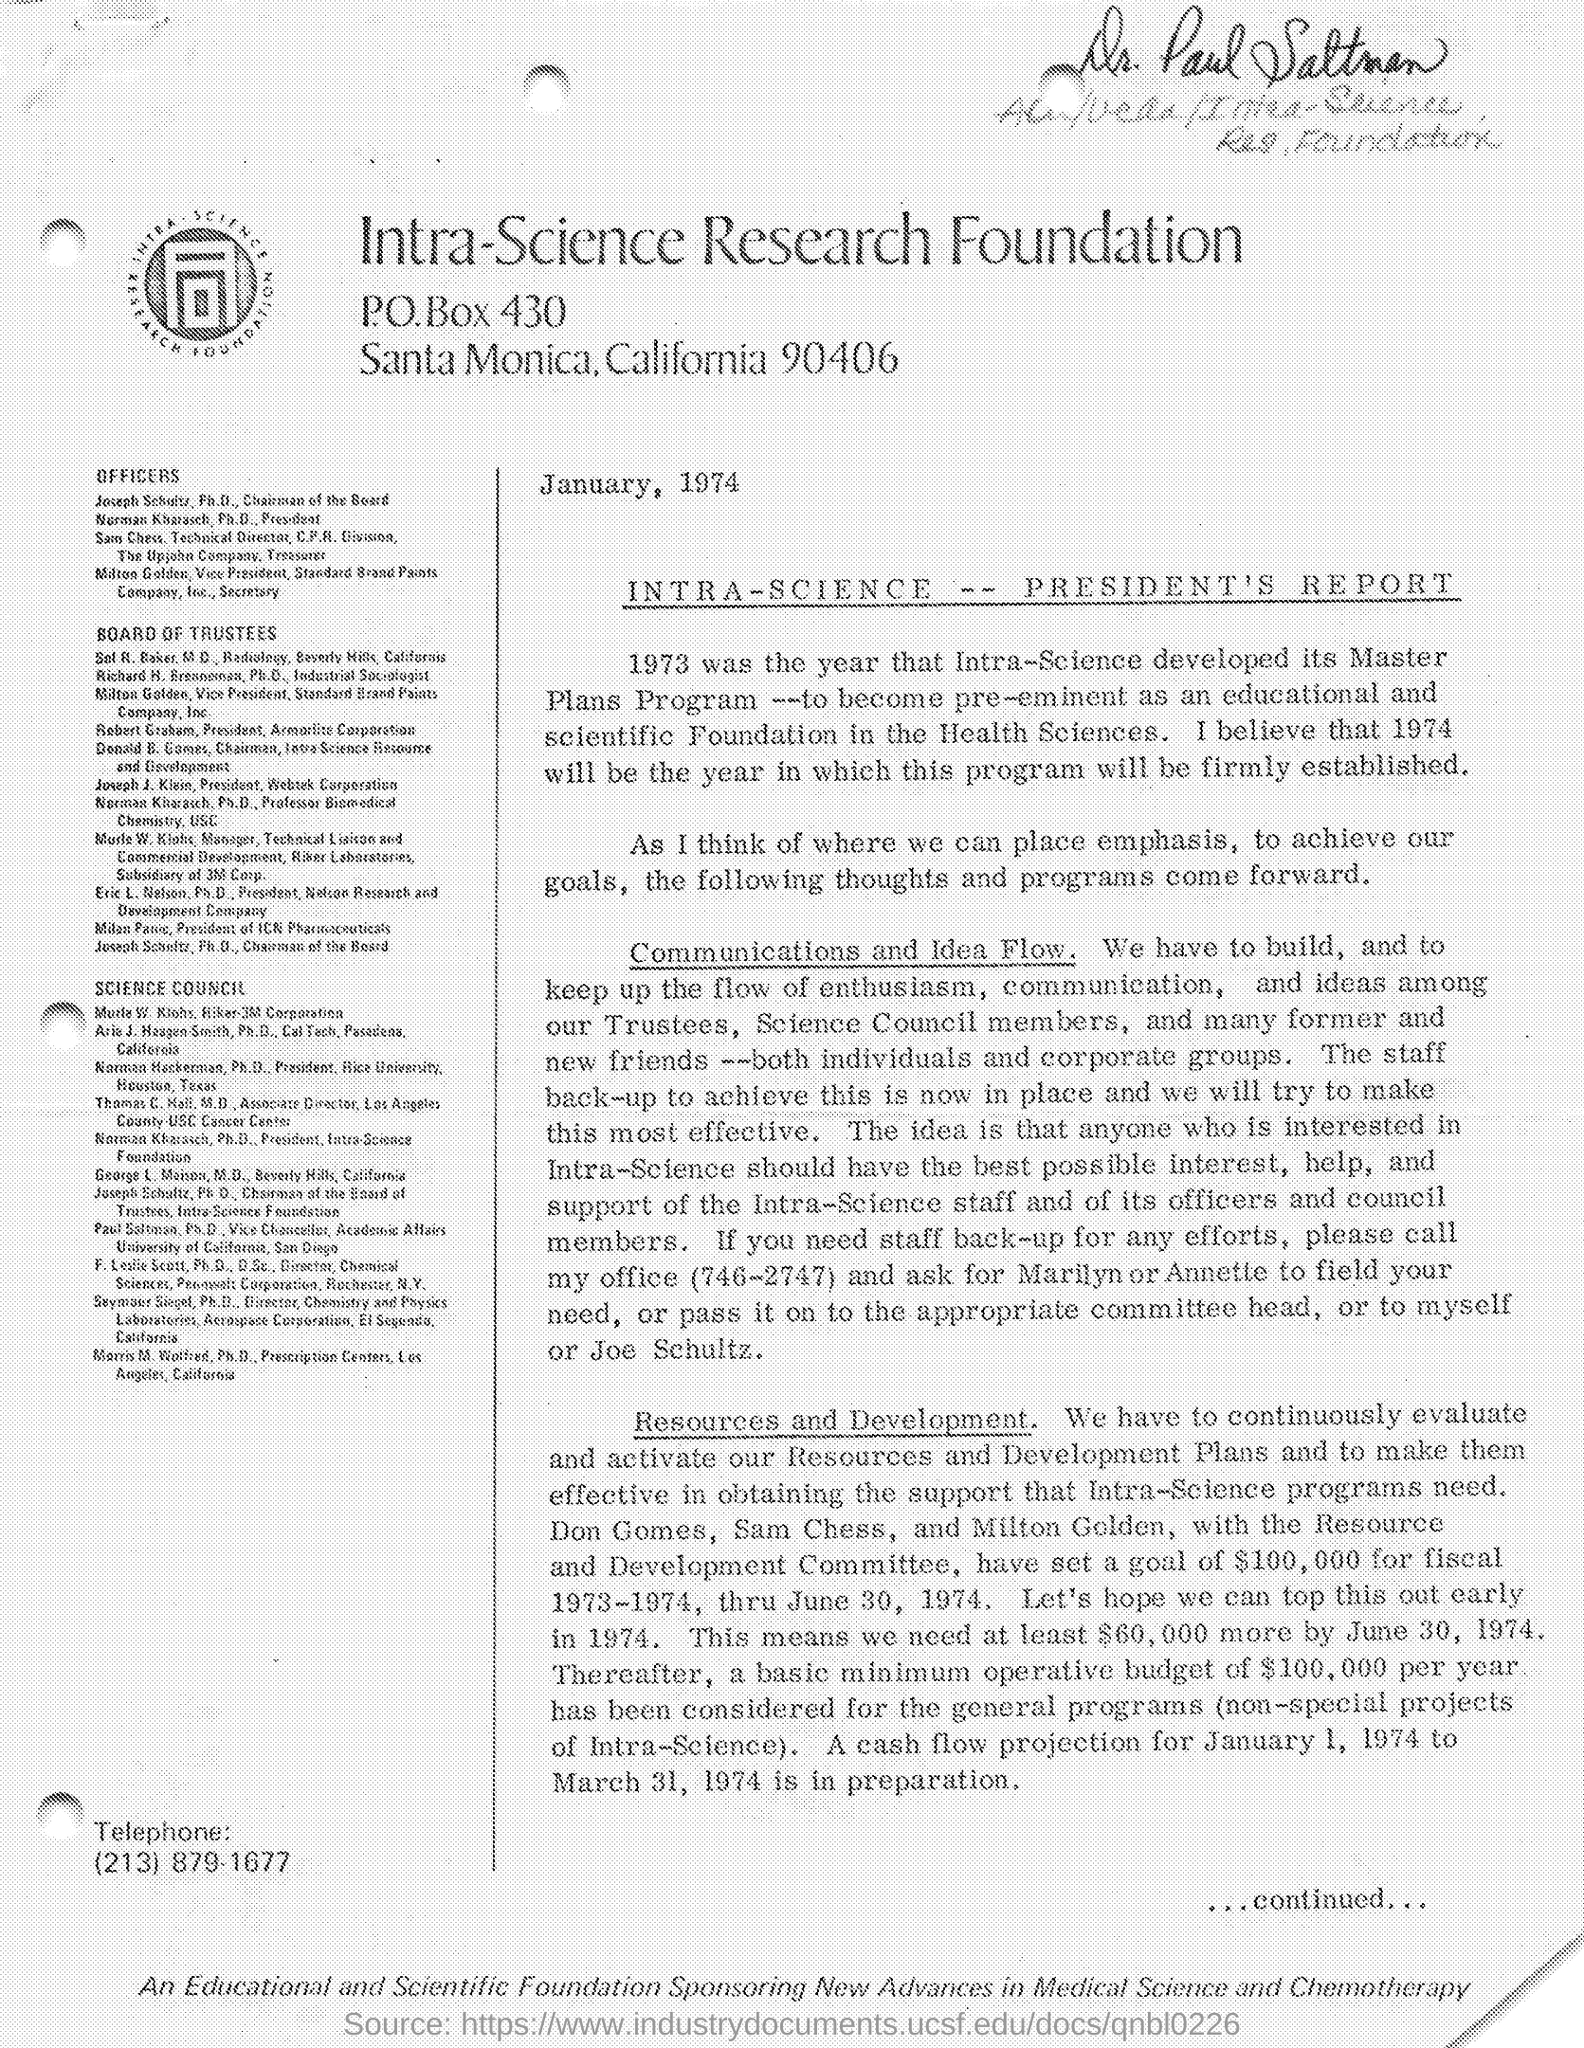Where to cal for staff back-up the efforts?
Your answer should be very brief. 746-2747. Who made goal of amount with Resource and Development Committee?
Keep it short and to the point. Don gomes, sam chess, and milton golden. What is the Goal amount?
Ensure brevity in your answer.  $100,000. Whats the duration of goal?
Provide a short and direct response. Fiscal 1973-1974. How many more dollars were needed by 30 June 1974?
Keep it short and to the point. At least $60,000. 